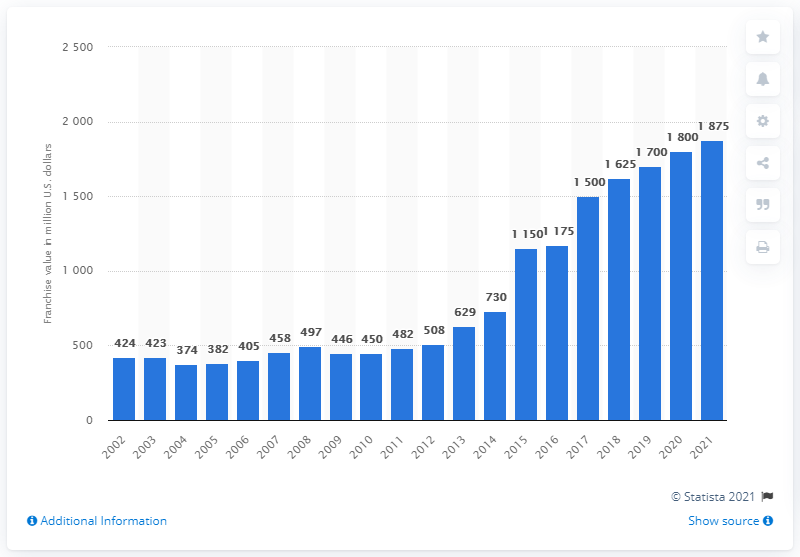Draw attention to some important aspects in this diagram. The estimated value of the Atlanta Braves in 2021 was approximately 1875. 